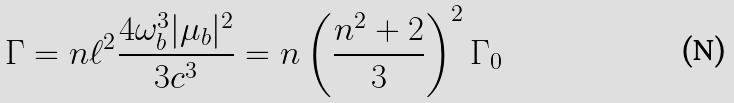<formula> <loc_0><loc_0><loc_500><loc_500>\Gamma = n \ell ^ { 2 } \frac { 4 \omega _ { b } ^ { 3 } | \mu _ { b } | ^ { 2 } } { 3 c ^ { 3 } } = n \left ( \frac { n ^ { 2 } + 2 } { 3 } \right ) ^ { 2 } \Gamma _ { 0 }</formula> 